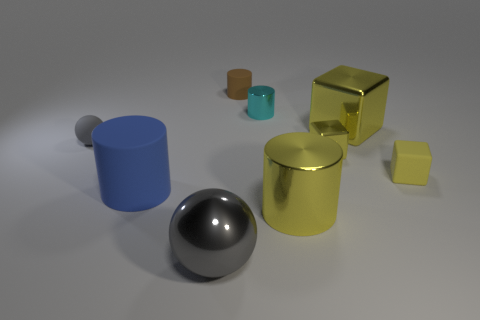What number of shiny objects are big cyan cylinders or blue things?
Offer a very short reply. 0. What number of cyan objects are shiny spheres or small shiny cylinders?
Your answer should be compact. 1. There is a big metallic thing behind the small yellow metal block; is it the same color as the shiny sphere?
Offer a very short reply. No. Is the large block made of the same material as the brown cylinder?
Offer a terse response. No. Are there the same number of tiny matte things that are to the left of the small matte cylinder and yellow rubber objects that are on the left side of the cyan metal cylinder?
Offer a terse response. No. There is a big yellow thing that is the same shape as the tiny brown rubber object; what is it made of?
Offer a terse response. Metal. The yellow metallic object that is in front of the large cylinder on the left side of the cylinder behind the small cyan shiny cylinder is what shape?
Give a very brief answer. Cylinder. Are there more blue rubber objects behind the tiny matte cube than tiny gray matte balls?
Your answer should be very brief. No. There is a tiny metallic object that is left of the small yellow shiny thing; is it the same shape as the big gray object?
Your answer should be compact. No. There is a large cylinder that is right of the cyan metallic object; what material is it?
Offer a terse response. Metal. 